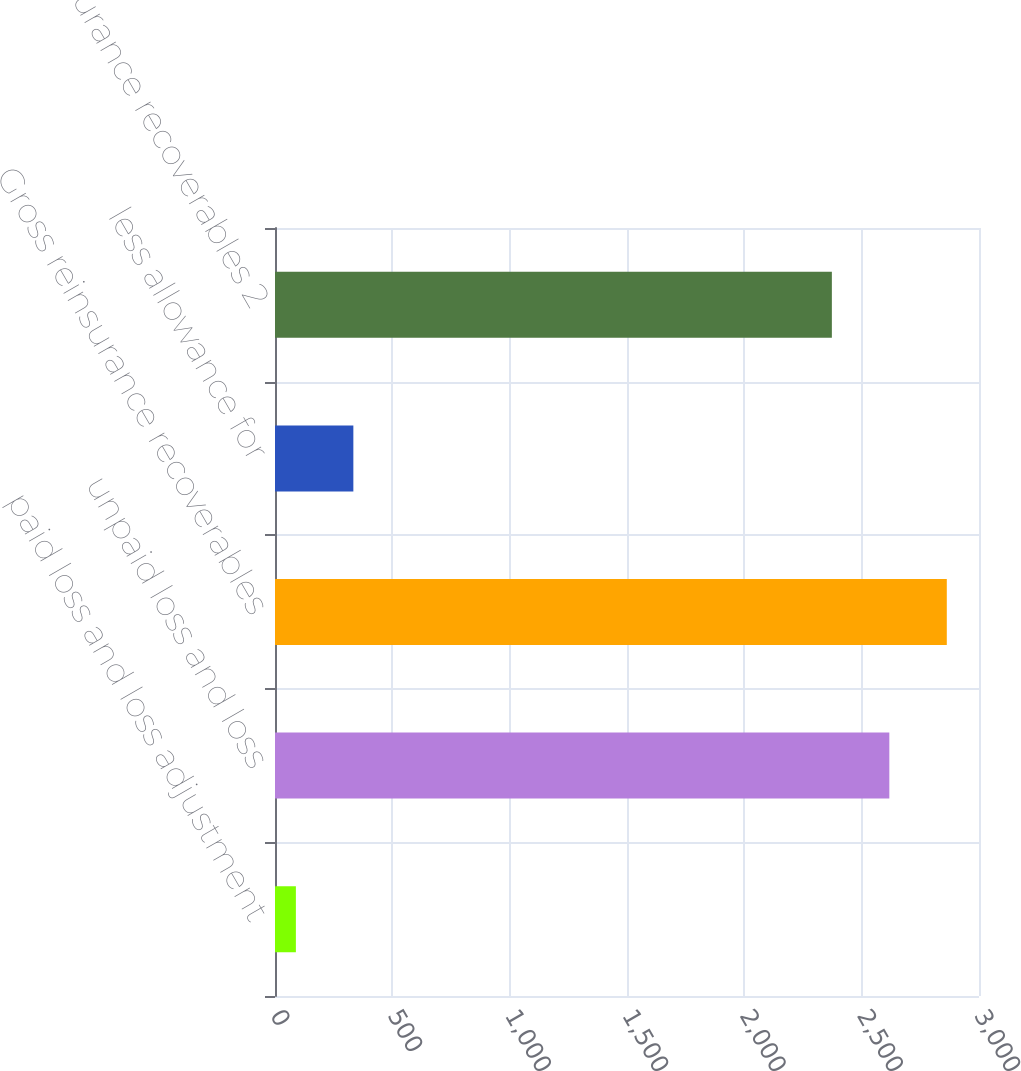<chart> <loc_0><loc_0><loc_500><loc_500><bar_chart><fcel>paid loss and loss adjustment<fcel>unpaid loss and loss<fcel>Gross reinsurance recoverables<fcel>less allowance for<fcel>Net reinsurance recoverables 2<nl><fcel>89<fcel>2617.9<fcel>2862.8<fcel>333.9<fcel>2373<nl></chart> 